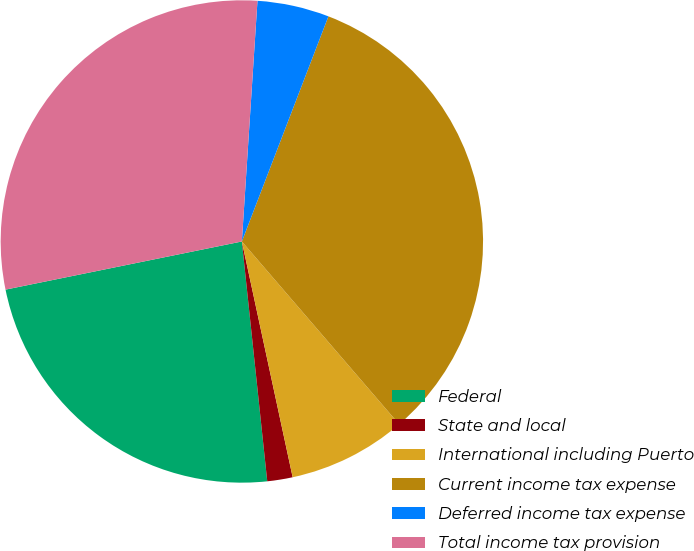<chart> <loc_0><loc_0><loc_500><loc_500><pie_chart><fcel>Federal<fcel>State and local<fcel>International including Puerto<fcel>Current income tax expense<fcel>Deferred income tax expense<fcel>Total income tax provision<nl><fcel>23.48%<fcel>1.7%<fcel>7.93%<fcel>32.85%<fcel>4.81%<fcel>29.23%<nl></chart> 